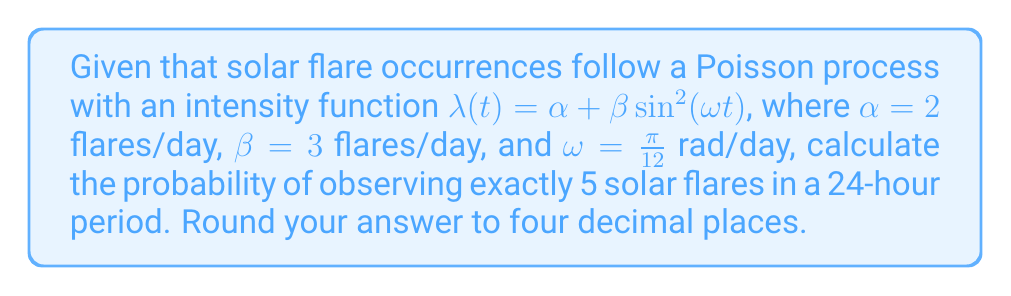Teach me how to tackle this problem. Let's approach this step-by-step:

1) For a non-homogeneous Poisson process, the number of events N(t) in an interval [0, t] follows a Poisson distribution with mean $\Lambda(t) = \int_0^t \lambda(s) ds$.

2) We need to calculate $\Lambda(24)$:

   $$\Lambda(24) = \int_0^{24} (\alpha + \beta \sin^2(\omega s)) ds$$

3) Let's break this integral down:

   $$\Lambda(24) = \int_0^{24} \alpha ds + \int_0^{24} \beta \sin^2(\omega s) ds$$

4) The first part is straightforward:

   $$\int_0^{24} \alpha ds = 24\alpha = 24 \cdot 2 = 48$$

5) For the second part, we can use the trigonometric identity $\sin^2(x) = \frac{1 - \cos(2x)}{2}$:

   $$\int_0^{24} \beta \sin^2(\omega s) ds = \frac{\beta}{2} \int_0^{24} (1 - \cos(2\omega s)) ds$$

6) Solving this integral:

   $$\frac{\beta}{2} [s - \frac{1}{2\omega}\sin(2\omega s)]_0^{24} = \frac{3}{2} [24 - \frac{12}{\pi}\sin(\pi)] = 36$$

7) Therefore, $\Lambda(24) = 48 + 36 = 84$

8) The probability of exactly 5 events in a Poisson process is given by:

   $$P(N(24) = 5) = \frac{e^{-\Lambda(24)} \Lambda(24)^5}{5!}$$

9) Substituting our value:

   $$P(N(24) = 5) = \frac{e^{-84} 84^5}{5!} \approx 0.0001$$
Answer: 0.0001 